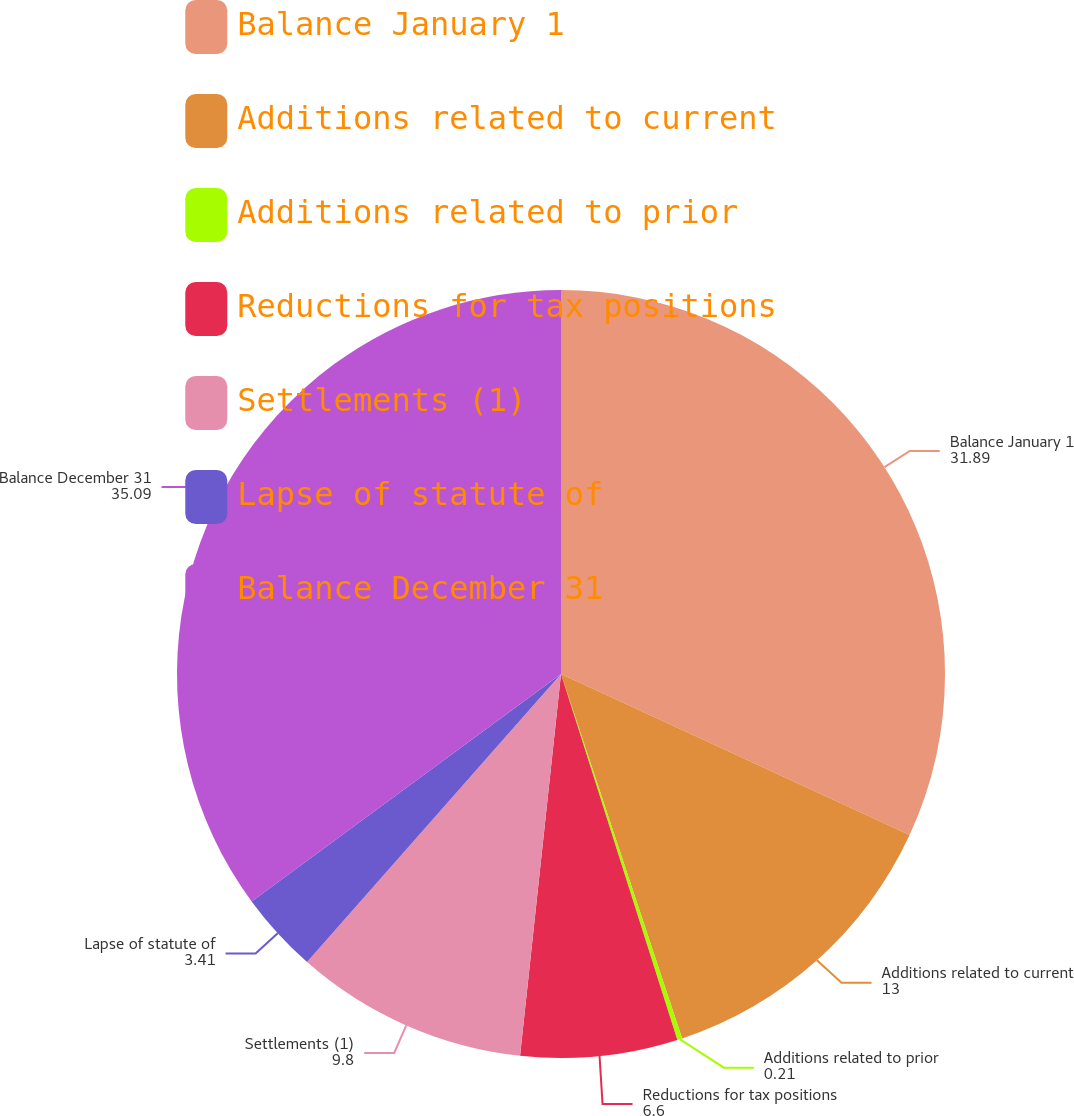<chart> <loc_0><loc_0><loc_500><loc_500><pie_chart><fcel>Balance January 1<fcel>Additions related to current<fcel>Additions related to prior<fcel>Reductions for tax positions<fcel>Settlements (1)<fcel>Lapse of statute of<fcel>Balance December 31<nl><fcel>31.89%<fcel>13.0%<fcel>0.21%<fcel>6.6%<fcel>9.8%<fcel>3.41%<fcel>35.09%<nl></chart> 